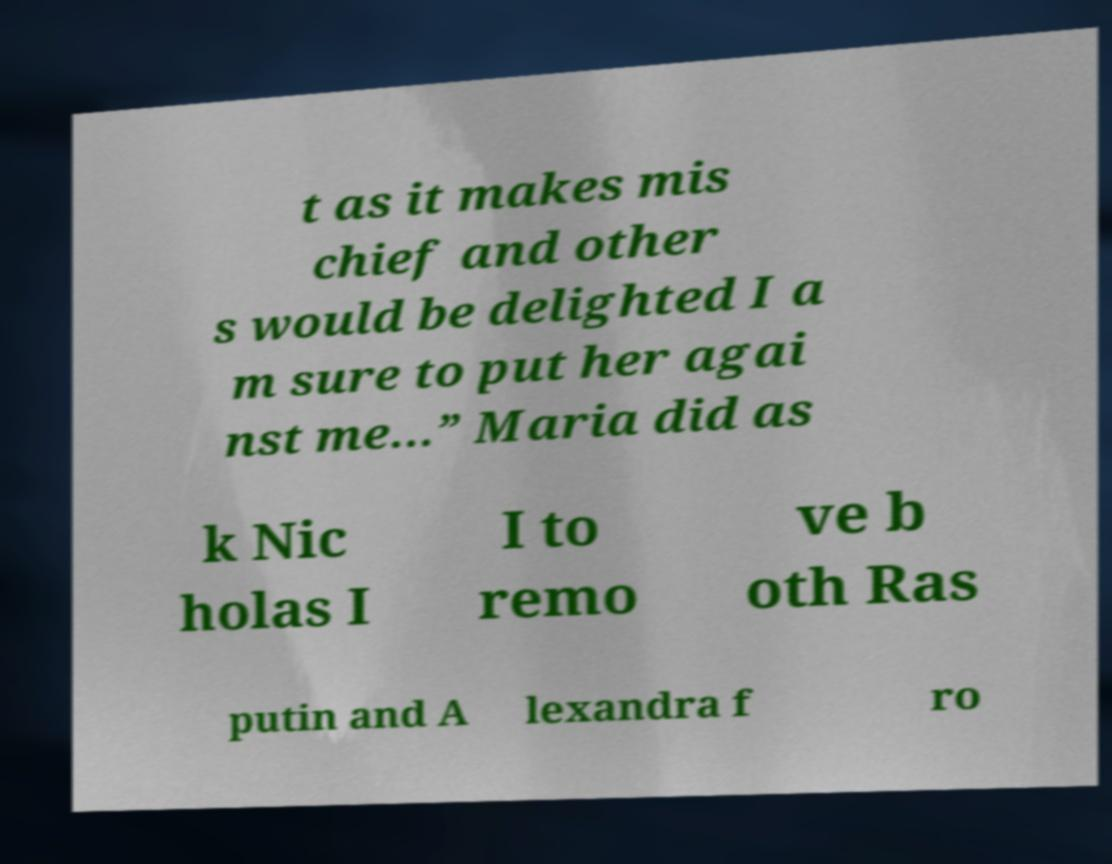Please identify and transcribe the text found in this image. t as it makes mis chief and other s would be delighted I a m sure to put her agai nst me…” Maria did as k Nic holas I I to remo ve b oth Ras putin and A lexandra f ro 